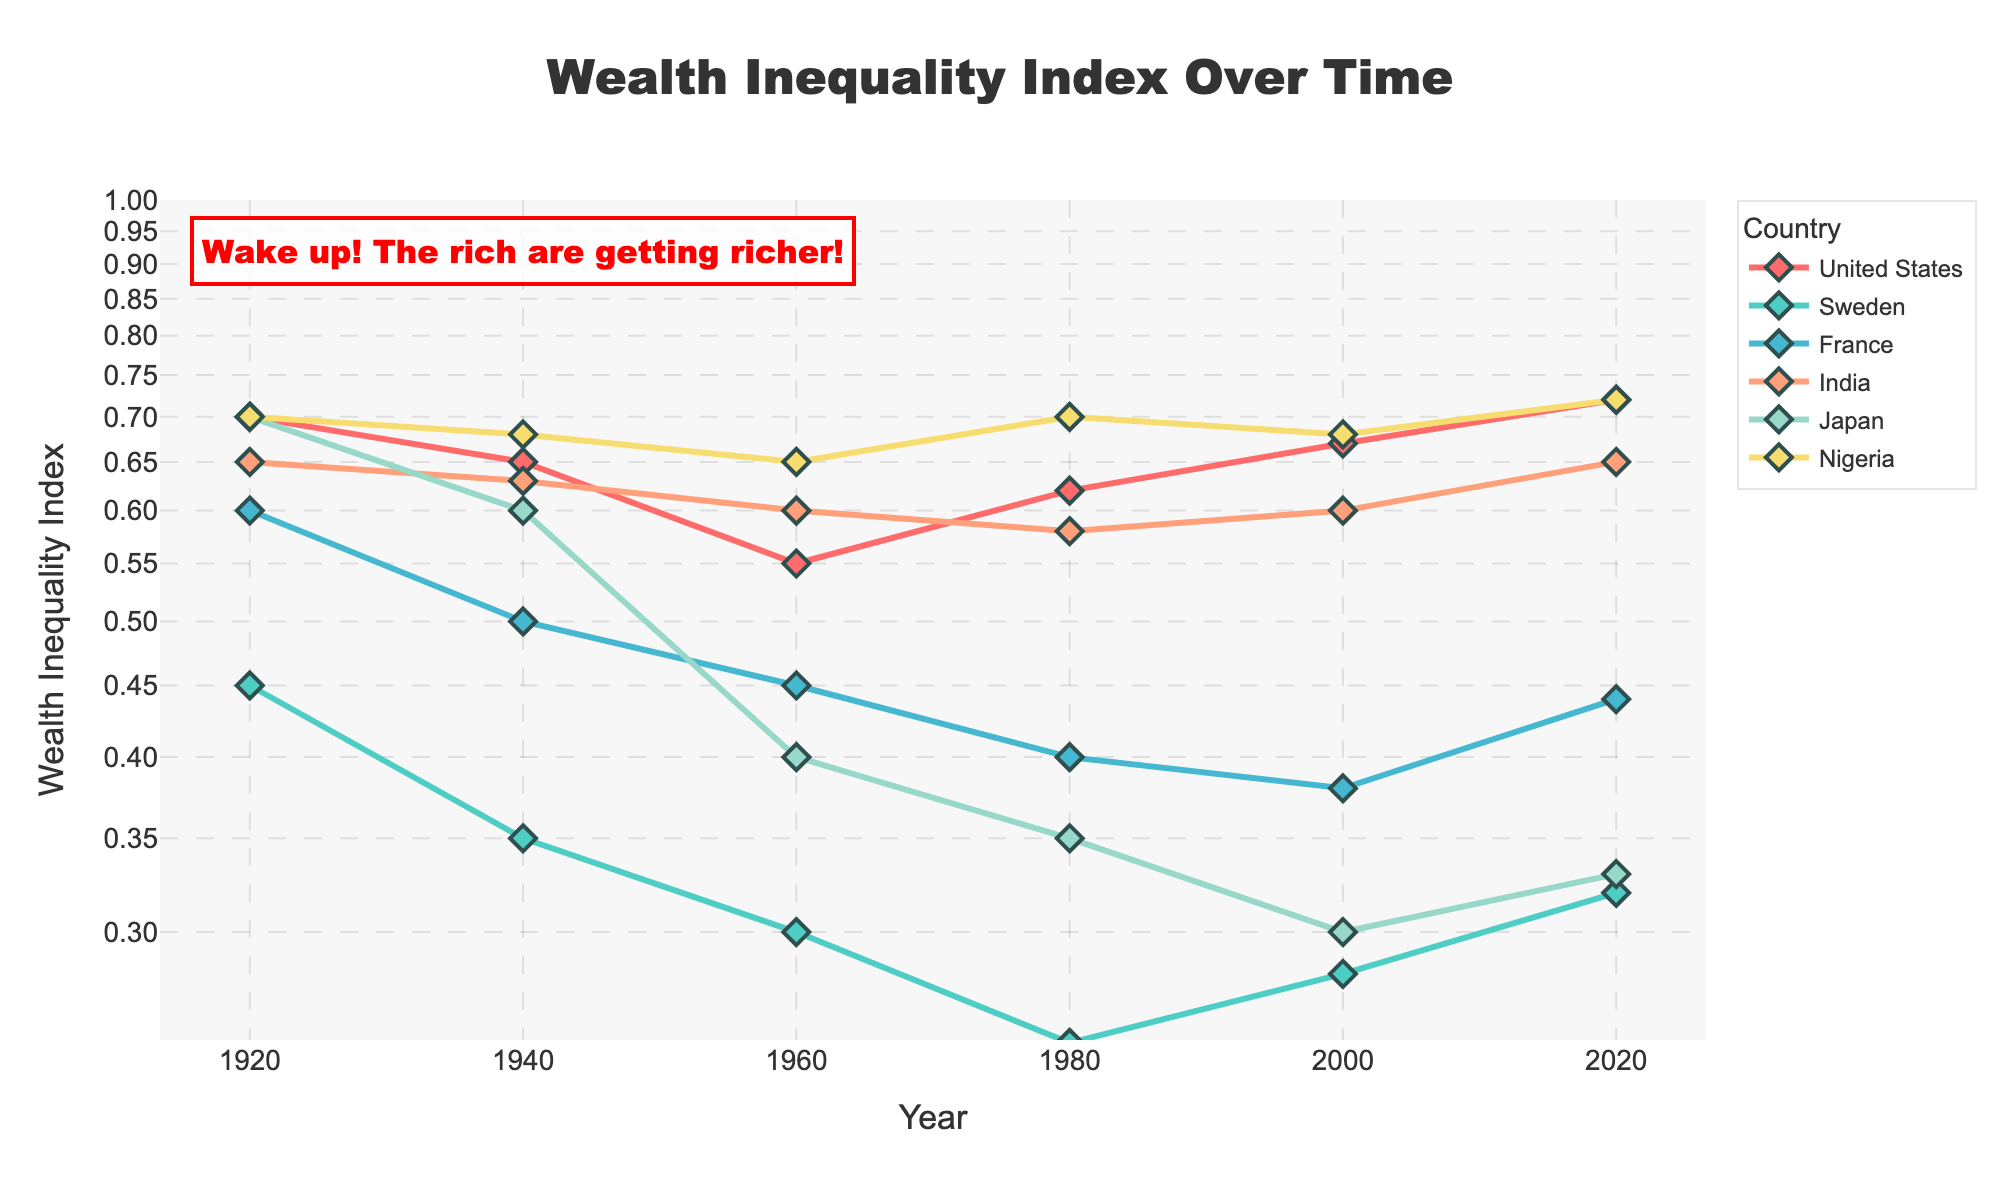What is the overall title of the figure? The title is usually positioned at the top of the figure. For this figure, it reads "Wealth Inequality Index Over Time".
Answer: Wealth Inequality Index Over Time Which country shows the highest wealth inequality index in recent year 2020? By looking at the data points for 2020, the United States and Nigeria both have the highest value, which is approximately 0.72.
Answer: United States and Nigeria What is the range of wealth inequality indices displayed on the y-axis? The y-axis is using log scale, with the range specified as [-0.6, 0] based on log values. This corresponds to an actual range from around 0.25 to 1 on a standard scale.
Answer: 0.25 to 1 How did the wealth inequality index change in Sweden from 1920 to 1980? To determine the change, we look at Sweden's data points in 1920 (0.45) and 1980 (0.25). The wealth inequality index decreased by 0.20 over these 60 years.
Answer: Decreased by 0.20 Among the countries listed, which had the lowest wealth inequality index in 1960? Check the 1960 data points for all countries. Sweden had the lowest value at that year, which is 0.3.
Answer: Sweden What was the change in wealth inequality index for France from 1920 to 2020? The index in France was 0.6 in 1920 and 0.44 in 2020. The change is a decrease of 0.16.
Answer: Decreased by 0.16 Which country had the most significant decrease in wealth inequality index over the last century? Comparing the data from 1920 to 2020 for all countries, Japan shows the most significant decrease from 0.7 to 0.33, a total reduction of 0.37.
Answer: Japan How is the wealth inequality trend in India from 1960 to 2020? In 1960, India's index was 0.6, and in 2020, it was 0.65, showing a slight overall increase of 0.05 over the period.
Answer: Slightly increased In 1940, which country had the second-highest wealth inequality index after the United States? In 1940, India had the highest index (0.63) after the United States (0.65).
Answer: India 